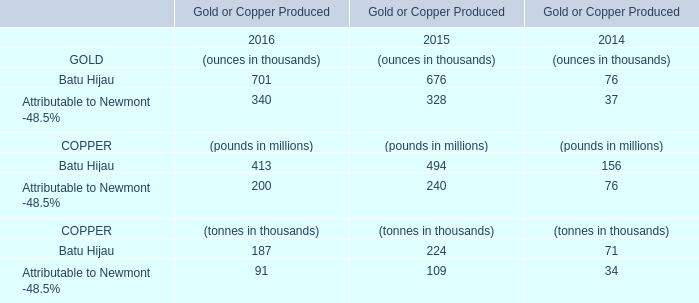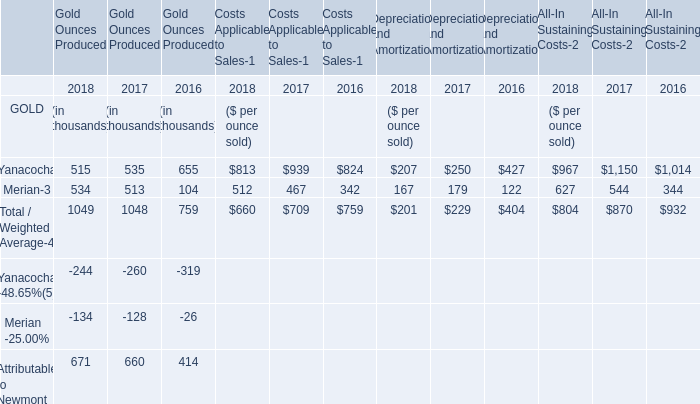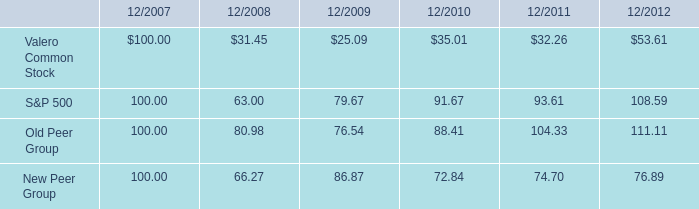What is the weight of the GOLD Produced in terms of the section by which the weight of GOLD Produced occupies the larger proportion in total amount,in 2018? (in thousand) 
Answer: 534. 